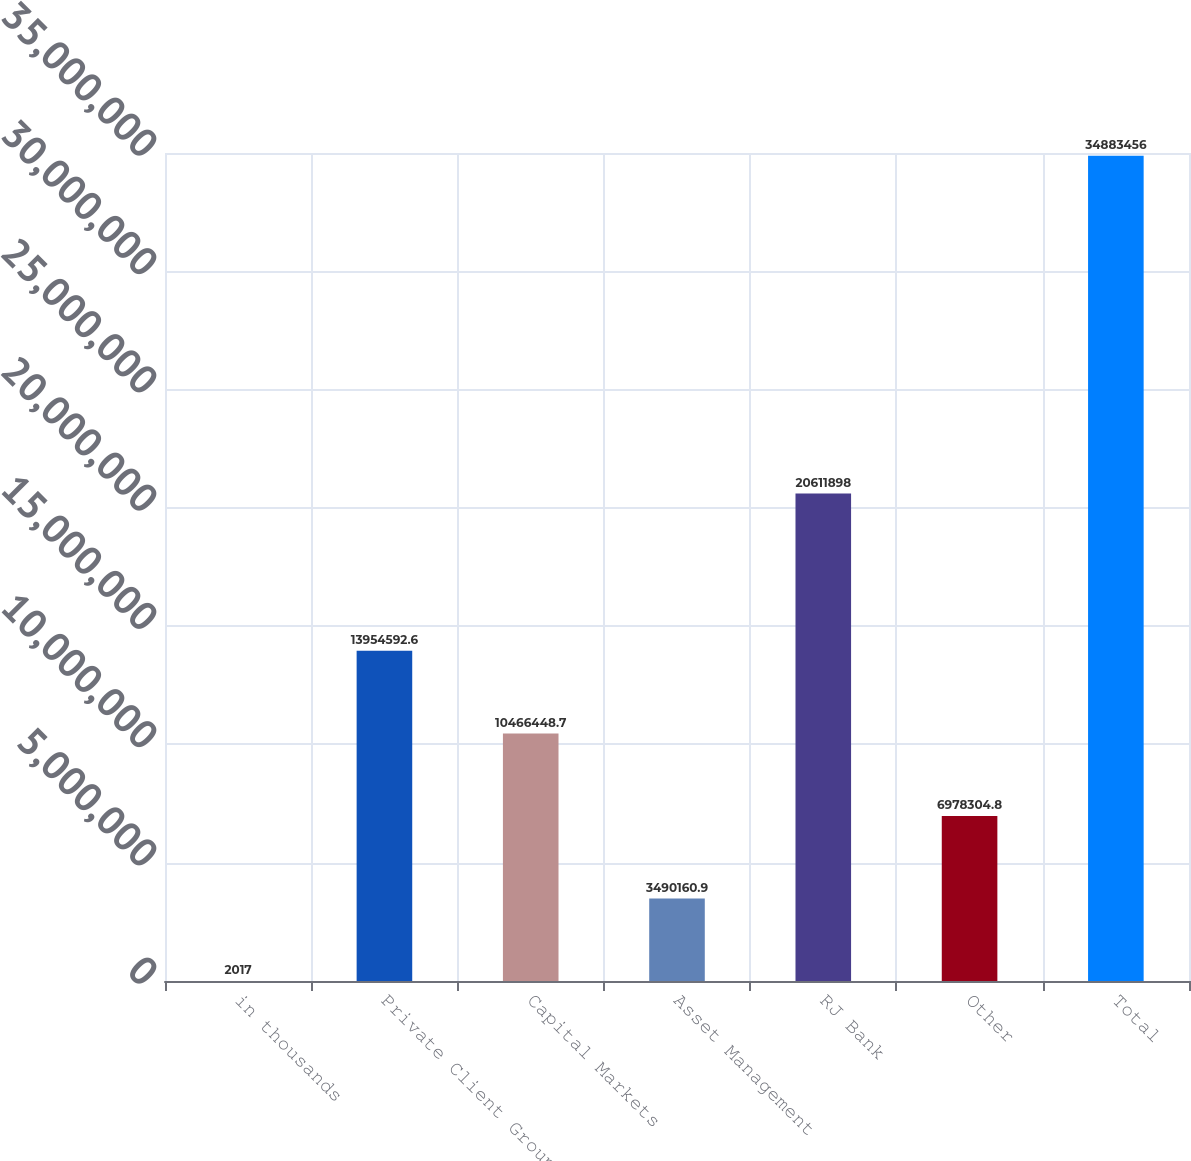Convert chart to OTSL. <chart><loc_0><loc_0><loc_500><loc_500><bar_chart><fcel>in thousands<fcel>Private Client Group<fcel>Capital Markets<fcel>Asset Management<fcel>RJ Bank<fcel>Other<fcel>Total<nl><fcel>2017<fcel>1.39546e+07<fcel>1.04664e+07<fcel>3.49016e+06<fcel>2.06119e+07<fcel>6.9783e+06<fcel>3.48835e+07<nl></chart> 